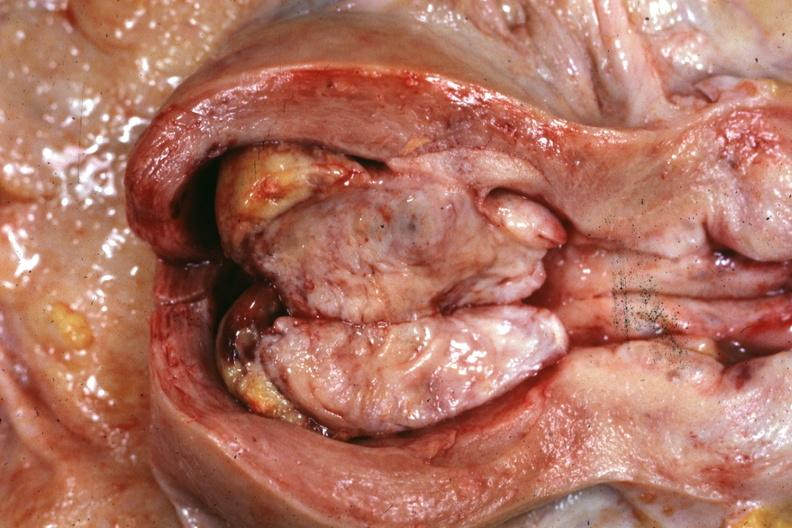does this image show opened uterus with polypoid mass?
Answer the question using a single word or phrase. Yes 